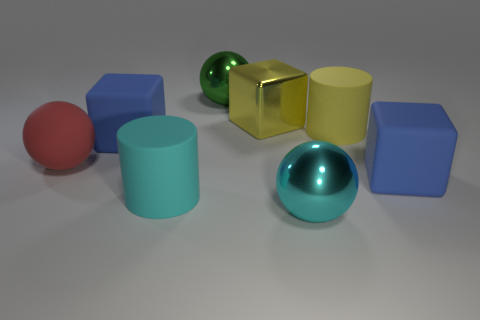Subtract all large green shiny balls. How many balls are left? 2 Add 1 big purple cylinders. How many objects exist? 9 Subtract all red balls. How many balls are left? 2 Subtract 1 yellow blocks. How many objects are left? 7 Subtract all cylinders. How many objects are left? 6 Subtract all brown cylinders. Subtract all green blocks. How many cylinders are left? 2 Subtract all purple cylinders. How many blue blocks are left? 2 Subtract all red spheres. Subtract all rubber spheres. How many objects are left? 6 Add 3 large cyan balls. How many large cyan balls are left? 4 Add 1 cyan things. How many cyan things exist? 3 